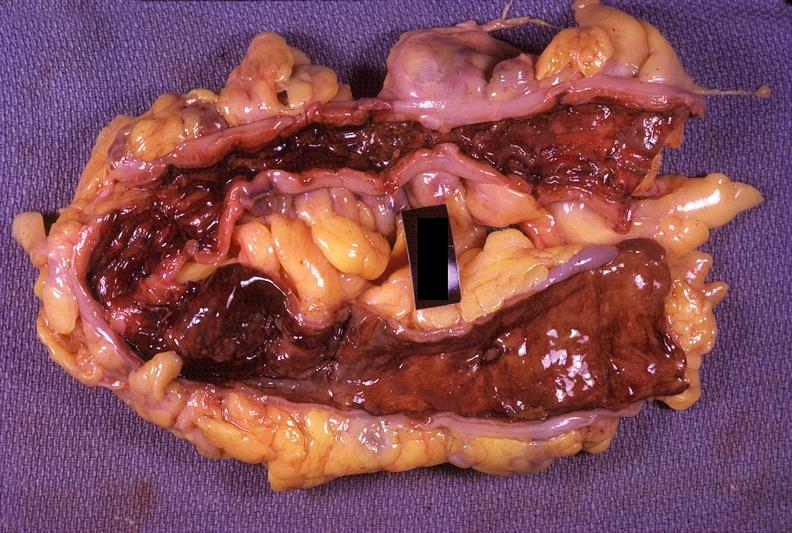s gastrointestinal present?
Answer the question using a single word or phrase. Yes 